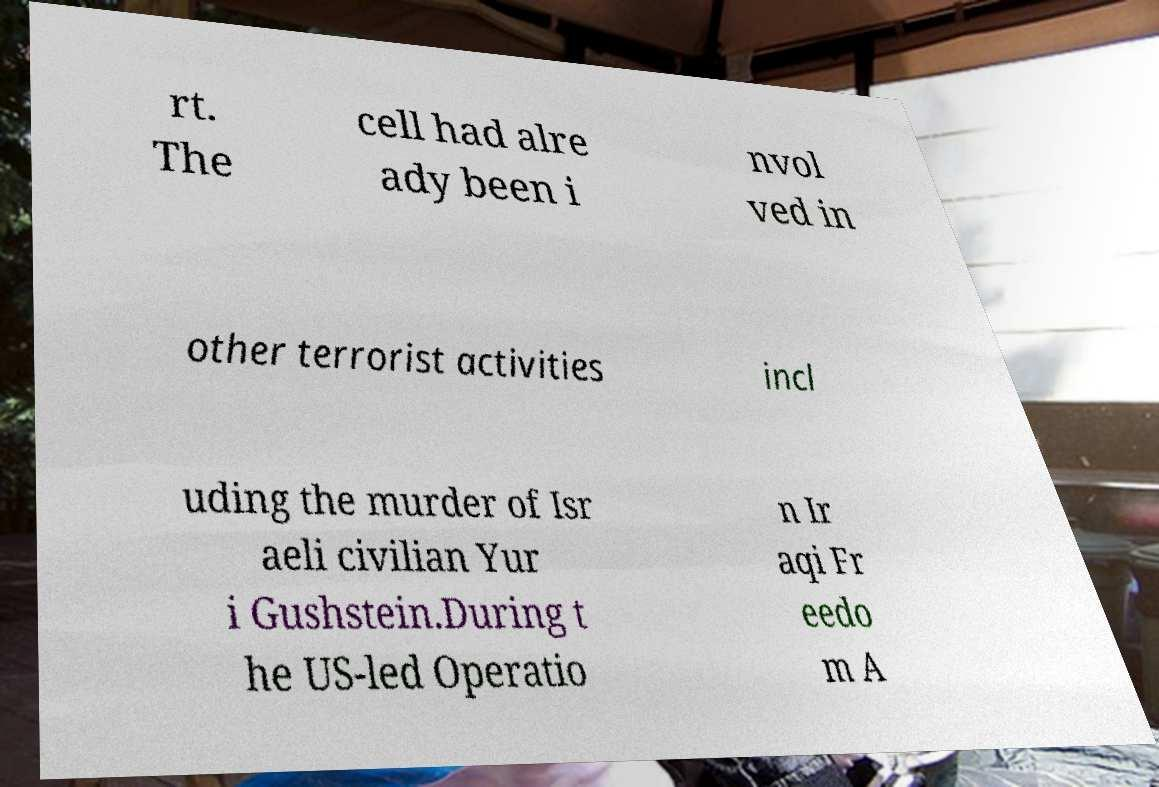For documentation purposes, I need the text within this image transcribed. Could you provide that? rt. The cell had alre ady been i nvol ved in other terrorist activities incl uding the murder of Isr aeli civilian Yur i Gushstein.During t he US-led Operatio n Ir aqi Fr eedo m A 